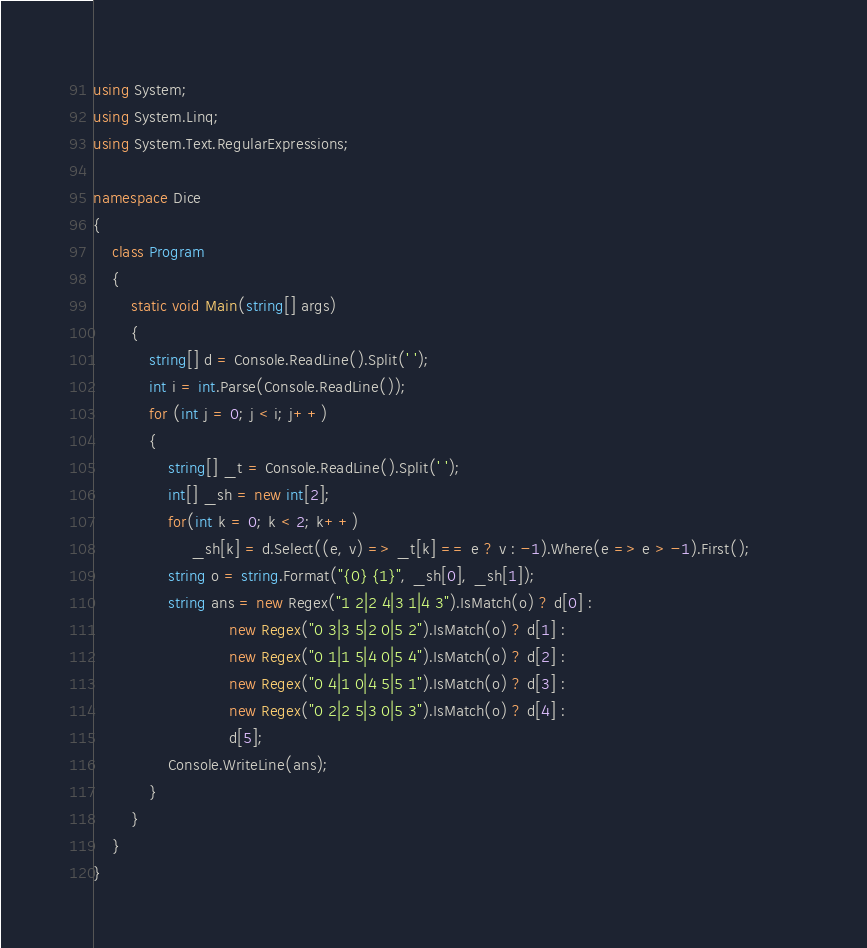Convert code to text. <code><loc_0><loc_0><loc_500><loc_500><_C#_>using System;
using System.Linq;
using System.Text.RegularExpressions;

namespace Dice
{
    class Program
    {
        static void Main(string[] args)
        {
            string[] d = Console.ReadLine().Split(' ');
            int i = int.Parse(Console.ReadLine());
            for (int j = 0; j < i; j++)
            {
                string[] _t = Console.ReadLine().Split(' ');
                int[] _sh = new int[2];
                for(int k = 0; k < 2; k++)
                     _sh[k] = d.Select((e, v) => _t[k] == e ? v : -1).Where(e => e > -1).First();          
                string o = string.Format("{0} {1}", _sh[0], _sh[1]);
                string ans = new Regex("1 2|2 4|3 1|4 3").IsMatch(o) ? d[0] :
                             new Regex("0 3|3 5|2 0|5 2").IsMatch(o) ? d[1] :
                             new Regex("0 1|1 5|4 0|5 4").IsMatch(o) ? d[2] :
                             new Regex("0 4|1 0|4 5|5 1").IsMatch(o) ? d[3] :
                             new Regex("0 2|2 5|3 0|5 3").IsMatch(o) ? d[4] :
                             d[5];
                Console.WriteLine(ans);
            }
        }
    }
}</code> 